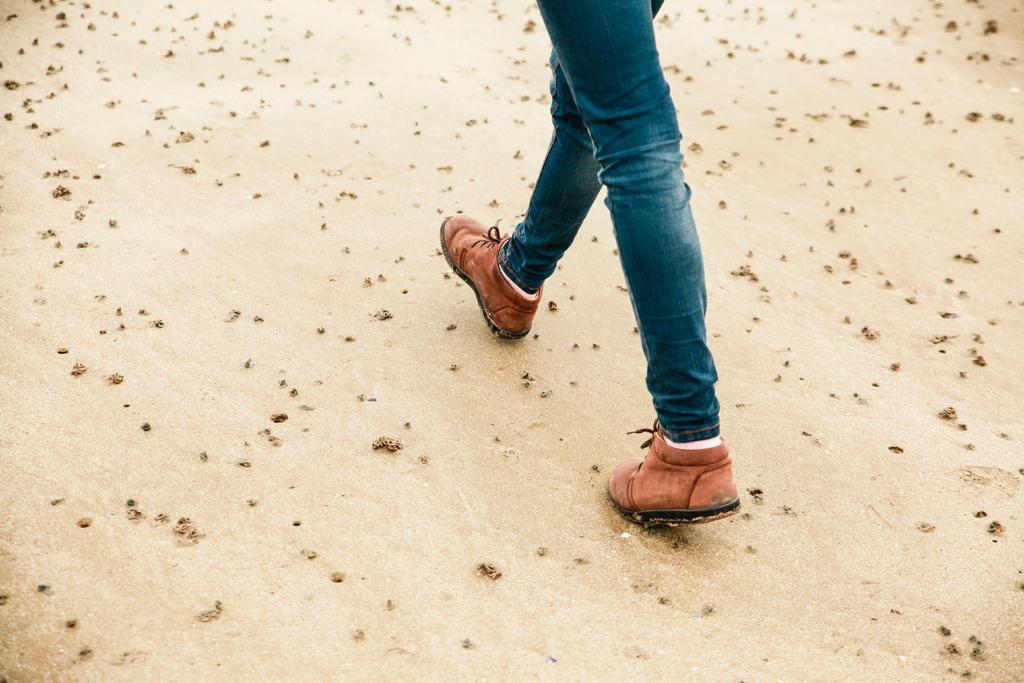Please provide a concise description of this image. In this picture I can see the person's leg who is wearing jeans and brown color shoes. At the bottom I can see the sand. 